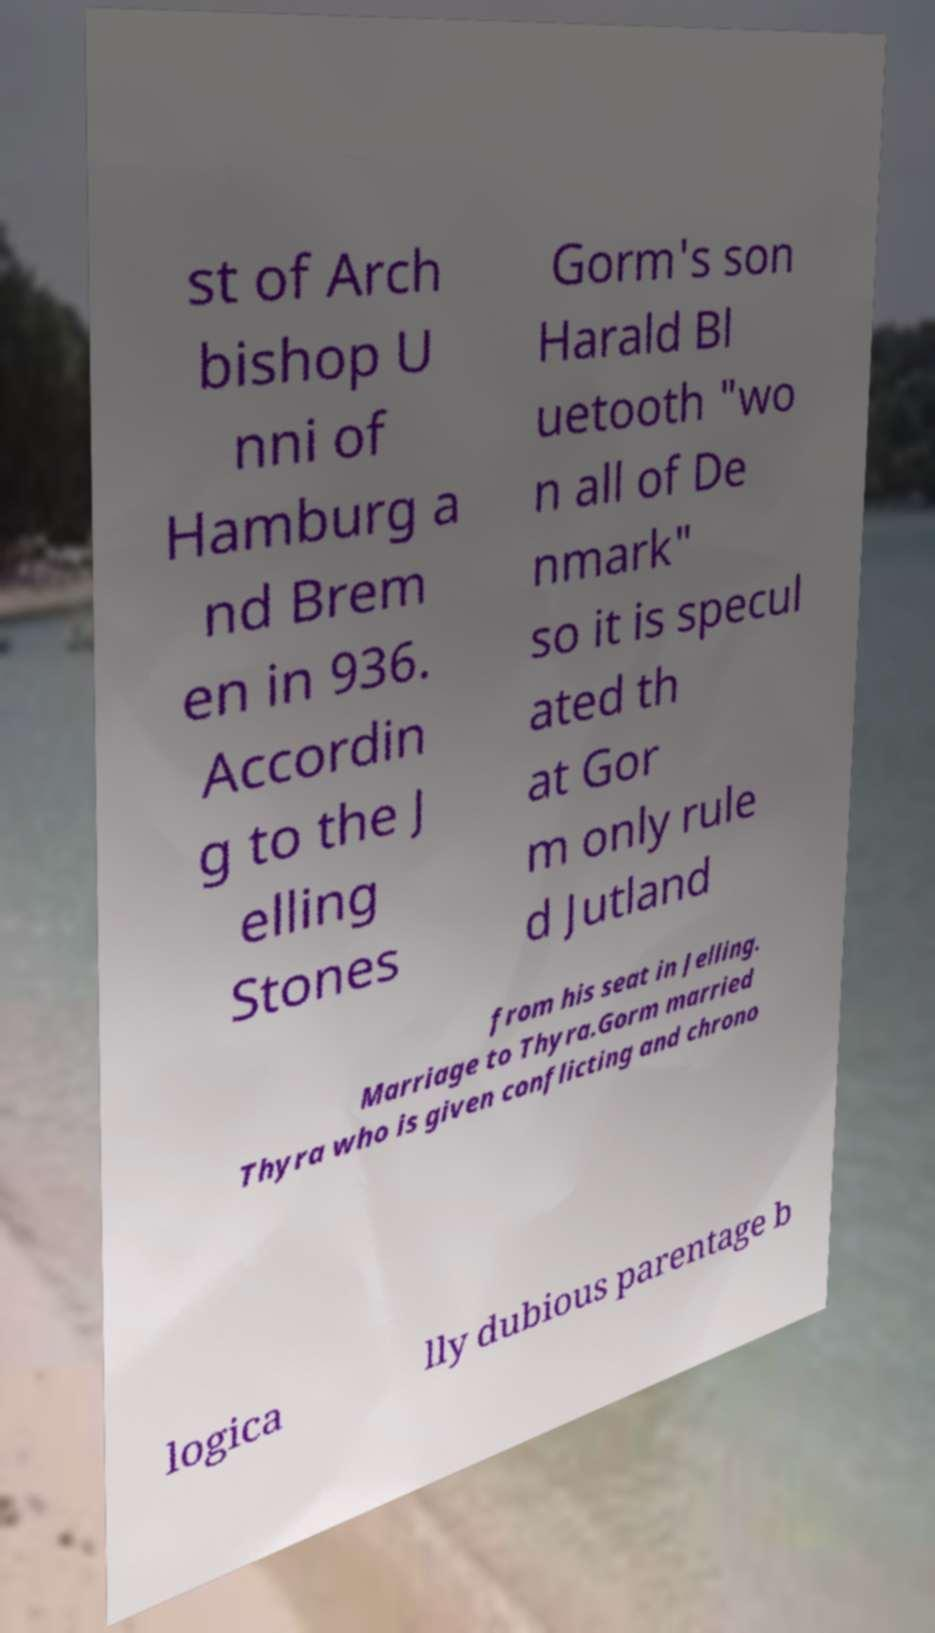Please read and relay the text visible in this image. What does it say? st of Arch bishop U nni of Hamburg a nd Brem en in 936. Accordin g to the J elling Stones Gorm's son Harald Bl uetooth "wo n all of De nmark" so it is specul ated th at Gor m only rule d Jutland from his seat in Jelling. Marriage to Thyra.Gorm married Thyra who is given conflicting and chrono logica lly dubious parentage b 